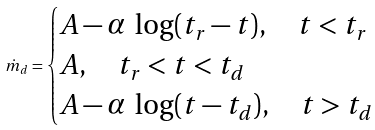Convert formula to latex. <formula><loc_0><loc_0><loc_500><loc_500>\dot { m } _ { d } = \begin{cases} A - \alpha \ \log ( t _ { r } - t ) , \quad t < t _ { r } \\ A , \quad t _ { r } < t < t _ { d } \\ A - \alpha \ \log ( t - t _ { d } ) , \quad t > t _ { d } \end{cases}</formula> 